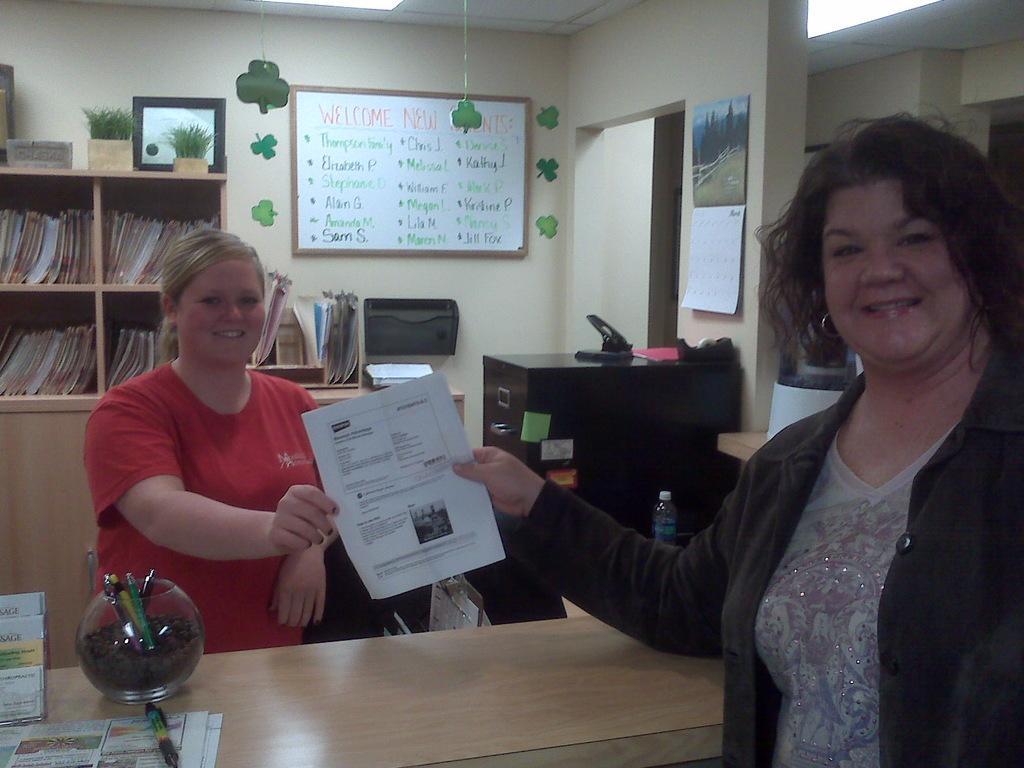Could you give a brief overview of what you see in this image? This picture is clicked in a room. To the right side there is a woman wearing a jacket, she is giving a paper to another woman, she is wearing a red t shirt. In the background there is a self full of books, board and a desk. In the bottom there is another table and a jar placed on it. 